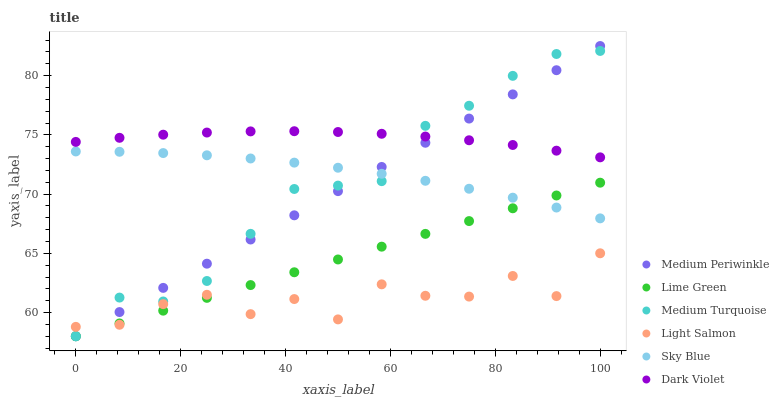Does Light Salmon have the minimum area under the curve?
Answer yes or no. Yes. Does Dark Violet have the maximum area under the curve?
Answer yes or no. Yes. Does Medium Periwinkle have the minimum area under the curve?
Answer yes or no. No. Does Medium Periwinkle have the maximum area under the curve?
Answer yes or no. No. Is Lime Green the smoothest?
Answer yes or no. Yes. Is Light Salmon the roughest?
Answer yes or no. Yes. Is Medium Periwinkle the smoothest?
Answer yes or no. No. Is Medium Periwinkle the roughest?
Answer yes or no. No. Does Medium Periwinkle have the lowest value?
Answer yes or no. Yes. Does Dark Violet have the lowest value?
Answer yes or no. No. Does Medium Periwinkle have the highest value?
Answer yes or no. Yes. Does Dark Violet have the highest value?
Answer yes or no. No. Is Light Salmon less than Dark Violet?
Answer yes or no. Yes. Is Sky Blue greater than Light Salmon?
Answer yes or no. Yes. Does Medium Periwinkle intersect Light Salmon?
Answer yes or no. Yes. Is Medium Periwinkle less than Light Salmon?
Answer yes or no. No. Is Medium Periwinkle greater than Light Salmon?
Answer yes or no. No. Does Light Salmon intersect Dark Violet?
Answer yes or no. No. 